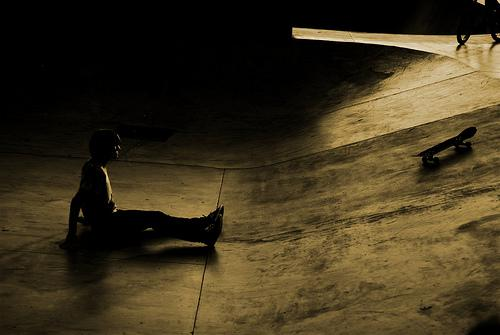Question: what is the person doing?
Choices:
A. Playing a game.
B. Running.
C. Sitting.
D. Flying a kit.
Answer with the letter. Answer: C Question: when was this picture taken?
Choices:
A. During the war.
B. At night.
C. May.
D. Noon.
Answer with the letter. Answer: B Question: why is the person on the ground?
Choices:
A. He is having a picnic.
B. He is tying his shoe.
C. She is playing a game.
D. He fell off his skateboard.
Answer with the letter. Answer: D 